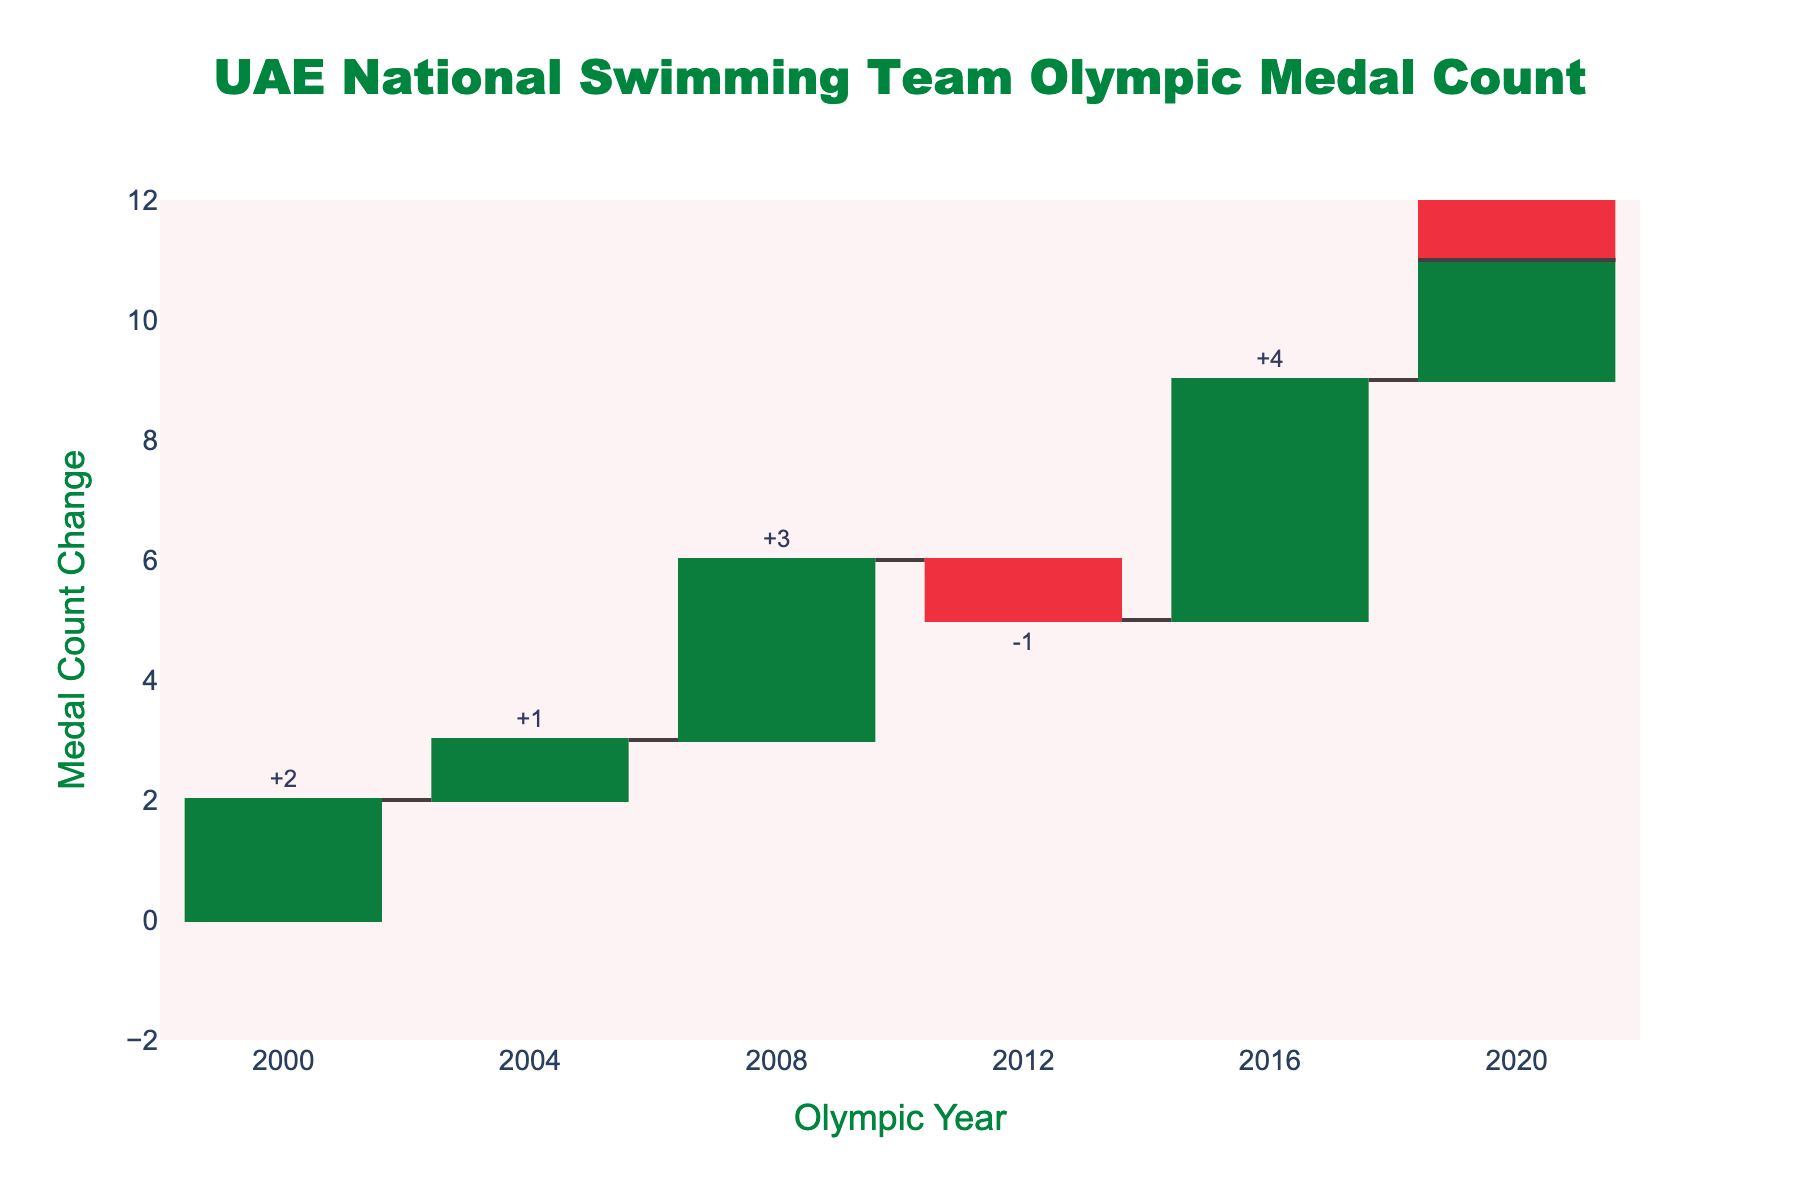What's the title of the chart? The title of the chart is the text presented at the top. It provides a brief description of the chart's content and purpose. The title in this chart is "UAE National Swimming Team Olympic Medal Count."
Answer: UAE National Swimming Team Olympic Medal Count How many Olympic years are displayed in the chart? The x-axis of the chart lists the Olympic years that are included in the data. By counting these years, we determine the total number of Olympic years displayed. The years are 2000, 2004, 2008, 2012, 2016, and 2020.
Answer: 6 years In which year did the UAE national swimming team have the highest increase in medal count? To determine the highest increase, we look for the tallest positive bar in the chart, which corresponds to the year with the largest positive change in medal count. The year 2016 has the highest increase, with a change of 4 medals.
Answer: 2016 What was the cumulative medal count by 2012? The cumulative medal count by any given year is shown as the cumulative value in the chart. For 2012, the cumulative medal count as shown in the figure is 5.
Answer: 5 Which year saw a decrease in the medal count and by how much? To identify a decrease, we look for a negative bar in the chart. The year 2012 has a negative change of -1 in the medal count.
Answer: 2012, -1 What is the overall trend in the UAE national swimming team’s medal count over the years? The overall trend in the medal count can be determined by observing the cumulative values over the years. Despite some fluctuations, the general trend shows an increase from 2 medals in 2000 to 11 medals in 2020.
Answer: Increasing How does the change in medal count from 2016 to 2020 compare with the change from 2008 to 2012? To compare these two periods, we observe the corresponding bars in the chart. From 2016 to 2020, the change was +2, while from 2008 to 2012, the change was -1. Thus, the change between 2016 to 2020 is more positive than from 2008 to 2012.
Answer: More positive What was the total incremental change in medal count from 2000 to 2020? To find the total incremental change, sum all the individual changes across the years. (2+1+3-1+4+2) which equals 11 - 2 (initial value in 2000), meaning the total incremental change is 9.
Answer: 9 Which color represents an increase in the medal count in the chart? Increase is represented by green bars in the chart. The distinct color for increases makes interpretation straightforward.
Answer: Green By how much did the medal count change from 2000 to 2004? The change from 2000 to 2004 is shown by a single bar identified by the year 2004. The change for this period is +1 as indicated in the figure.
Answer: +1 